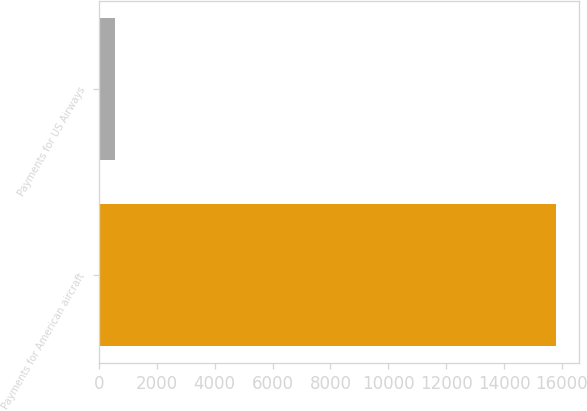Convert chart to OTSL. <chart><loc_0><loc_0><loc_500><loc_500><bar_chart><fcel>Payments for American aircraft<fcel>Payments for US Airways<nl><fcel>15794<fcel>552<nl></chart> 